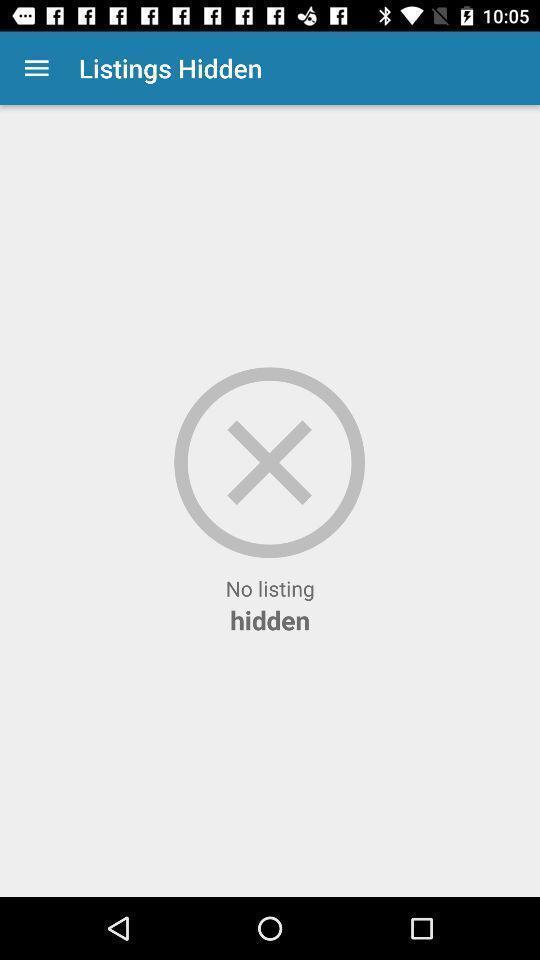Summarize the main components in this picture. Page showing no listing hidden. 